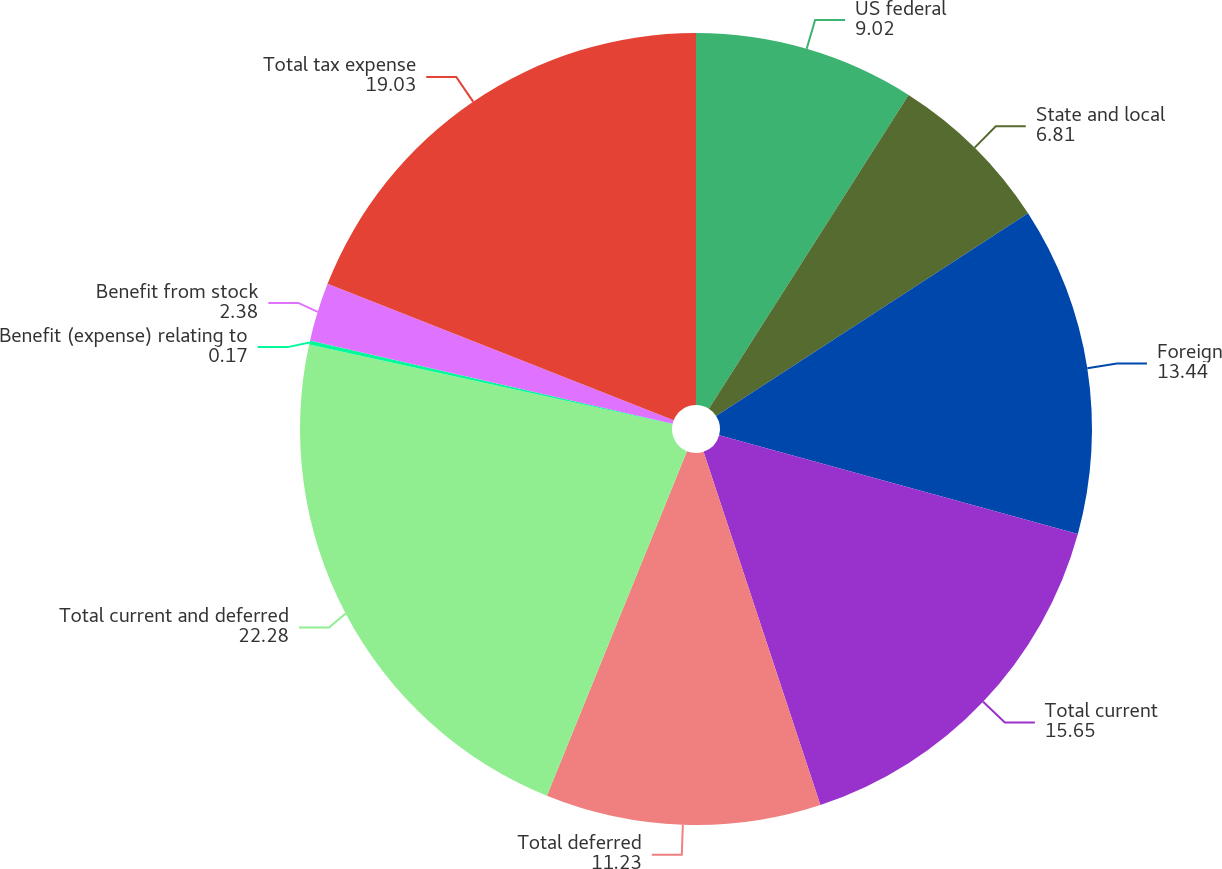Convert chart. <chart><loc_0><loc_0><loc_500><loc_500><pie_chart><fcel>US federal<fcel>State and local<fcel>Foreign<fcel>Total current<fcel>Total deferred<fcel>Total current and deferred<fcel>Benefit (expense) relating to<fcel>Benefit from stock<fcel>Total tax expense<nl><fcel>9.02%<fcel>6.81%<fcel>13.44%<fcel>15.65%<fcel>11.23%<fcel>22.28%<fcel>0.17%<fcel>2.38%<fcel>19.03%<nl></chart> 